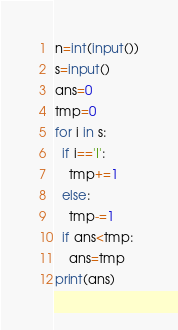Convert code to text. <code><loc_0><loc_0><loc_500><loc_500><_Python_>n=int(input())
s=input()
ans=0
tmp=0
for i in s:
  if i=='I':
    tmp+=1
  else:
    tmp-=1
  if ans<tmp:
    ans=tmp
print(ans)</code> 